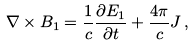<formula> <loc_0><loc_0><loc_500><loc_500>\nabla \times { B } _ { 1 } = \frac { 1 } { c } \frac { \partial { E } _ { 1 } } { \partial t } + \frac { 4 \pi } { c } { J } \, ,</formula> 